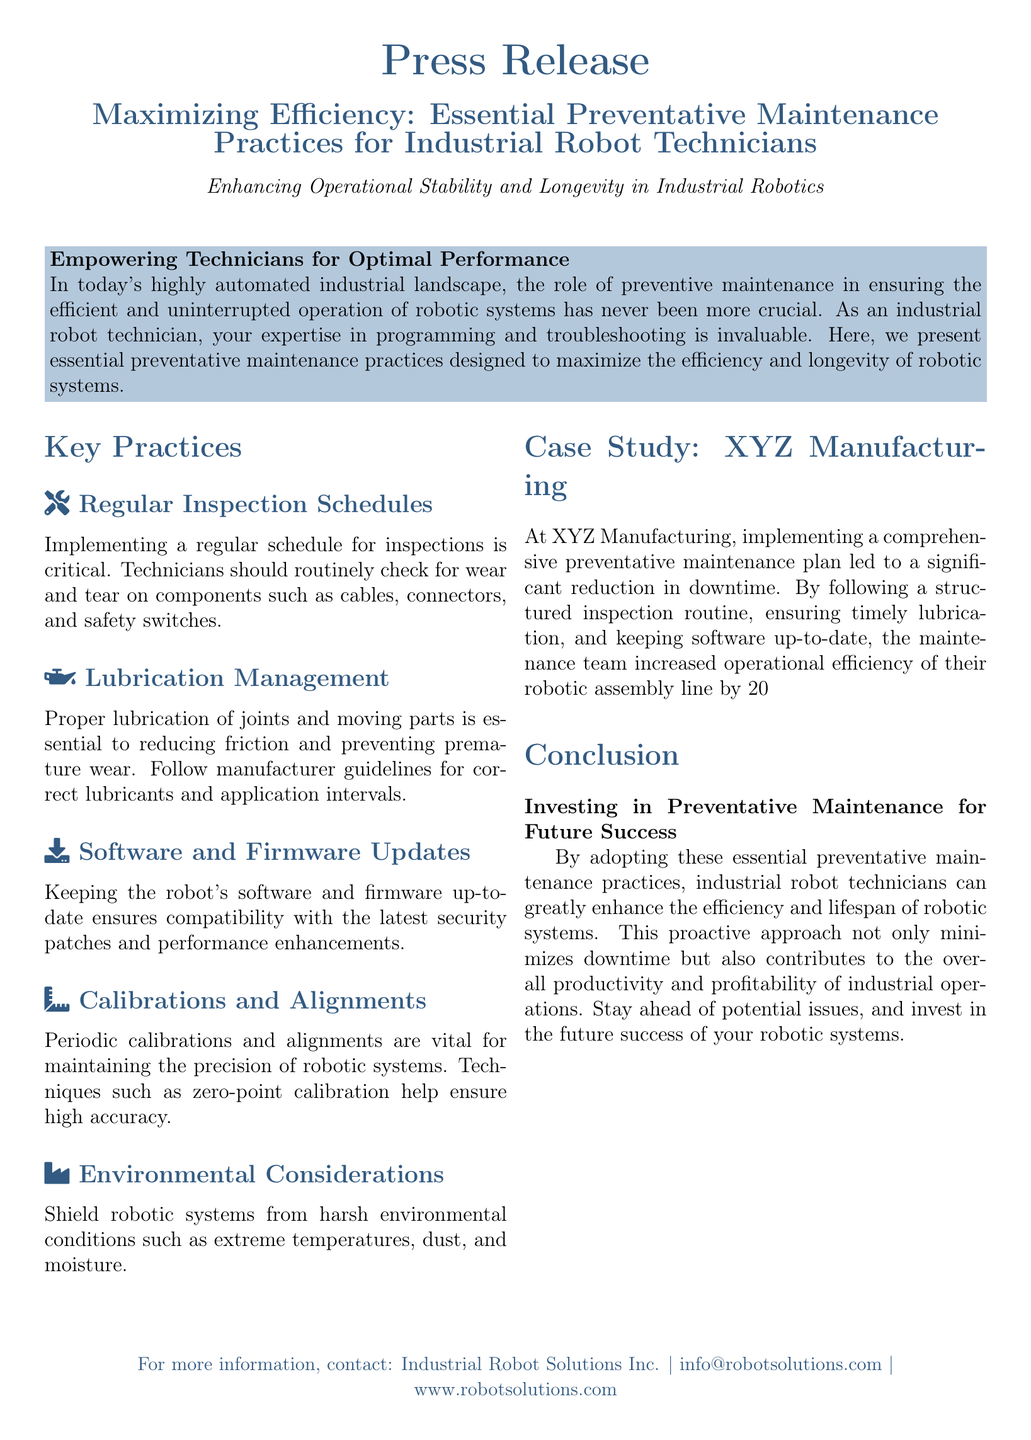what is the main topic of the press release? The main topic focuses on preventative maintenance practices for industrial robot technicians to enhance efficiency.
Answer: Essential Preventative Maintenance Practices for Industrial Robot Technicians how many key practices are listed in the document? The document outlines five key practices for preventative maintenance.
Answer: Five what is the title of the case study mentioned? The title of the case study highlights the results of a maintenance plan implemented in a specific manufacturing context.
Answer: XYZ Manufacturing what is the reported increase in operational efficiency after implementing maintenance practices? The case study indicates a measurable improvement in operational efficiency as a result of systematic maintenance efforts.
Answer: 20% which component types should technicians routinely inspect? The press release specifies certain components that require regular inspection to ensure system integrity.
Answer: Cables, connectors, and safety switches what is essential for reducing friction in robotic systems? The document emphasizes a particular maintenance task as crucial for reducing friction and wear on robotic parts.
Answer: Proper lubrication what should technicians avoid to prevent damaging robotic systems? A section of the document advises on environmental conditions that should be managed to protect robotic systems.
Answer: Harsh environmental conditions who can one contact for more information according to the document? The press release provides contact information for a specific company related to industrial robotics.
Answer: Industrial Robot Solutions Inc 